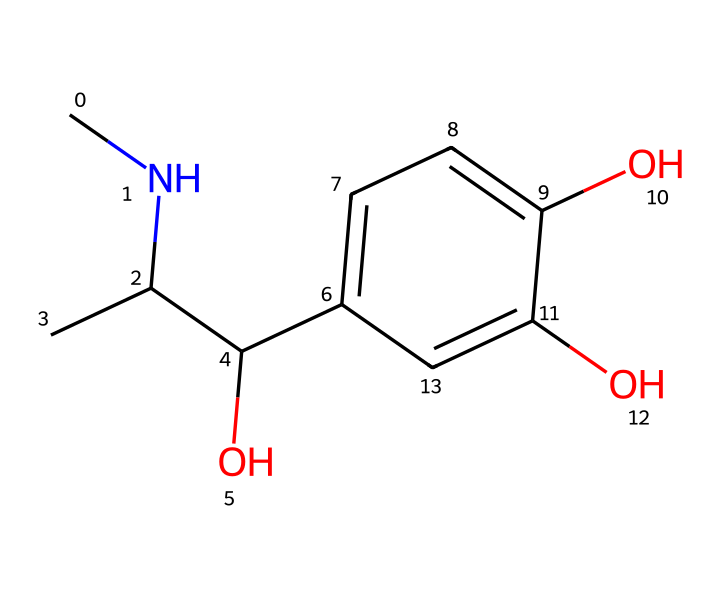What is the molecular formula of this chemical? By analyzing the SMILES representation, we can count the number of each type of atom present. The structure contains 11 carbon (C) atoms, 15 hydrogen (H) atoms, and 3 oxygen (O) atoms. Therefore, the molecular formula can be summarized as C11H15O3.
Answer: C11H15O3 How many hydroxyl (OH) groups are in this chemical? Reviewing the SMILES representation indicates the presence of hydroxyl (OH) groups, which are explicitly shown by the "O" followed by "c" in the structure. There are three such groups attached to the benzene ring in the chemical structure.
Answer: 3 What class of compounds does this chemical belong to? This chemical has a structure that is commonly associated with catecholamines due to the presence of a benzene ring and hydroxyl groups, specifically referring to adrenaline in this context. Therefore, it is classified as a catecholamine.
Answer: catecholamine How many chiral centers are present in the chemical? To identify chiral centers, we look for carbon atoms that have four different substituents. In this SMILES representation, the carbon attached to the nitrogen and hydroxyl groups shows four distinct substituents, indicating one chiral center.
Answer: 1 Which part of this chemical contributes to its role in the fight-or-flight response? The presence of the amine group (due to the nitrogen atom connected to carbon) is crucial as it is fundamental in neurotransmitter activity, contributing to adrenaline's role in the fight-or-flight response by interacting with adrenoreceptors.
Answer: amine group 